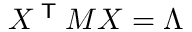Convert formula to latex. <formula><loc_0><loc_0><loc_500><loc_500>X ^ { T } M X = \Lambda</formula> 